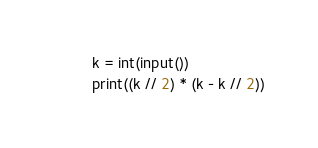<code> <loc_0><loc_0><loc_500><loc_500><_Python_>k = int(input())
print((k // 2) * (k - k // 2))</code> 